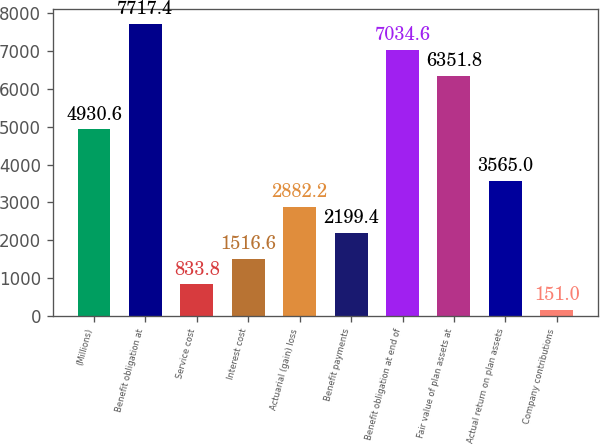<chart> <loc_0><loc_0><loc_500><loc_500><bar_chart><fcel>(Millions)<fcel>Benefit obligation at<fcel>Service cost<fcel>Interest cost<fcel>Actuarial (gain) loss<fcel>Benefit payments<fcel>Benefit obligation at end of<fcel>Fair value of plan assets at<fcel>Actual return on plan assets<fcel>Company contributions<nl><fcel>4930.6<fcel>7717.4<fcel>833.8<fcel>1516.6<fcel>2882.2<fcel>2199.4<fcel>7034.6<fcel>6351.8<fcel>3565<fcel>151<nl></chart> 